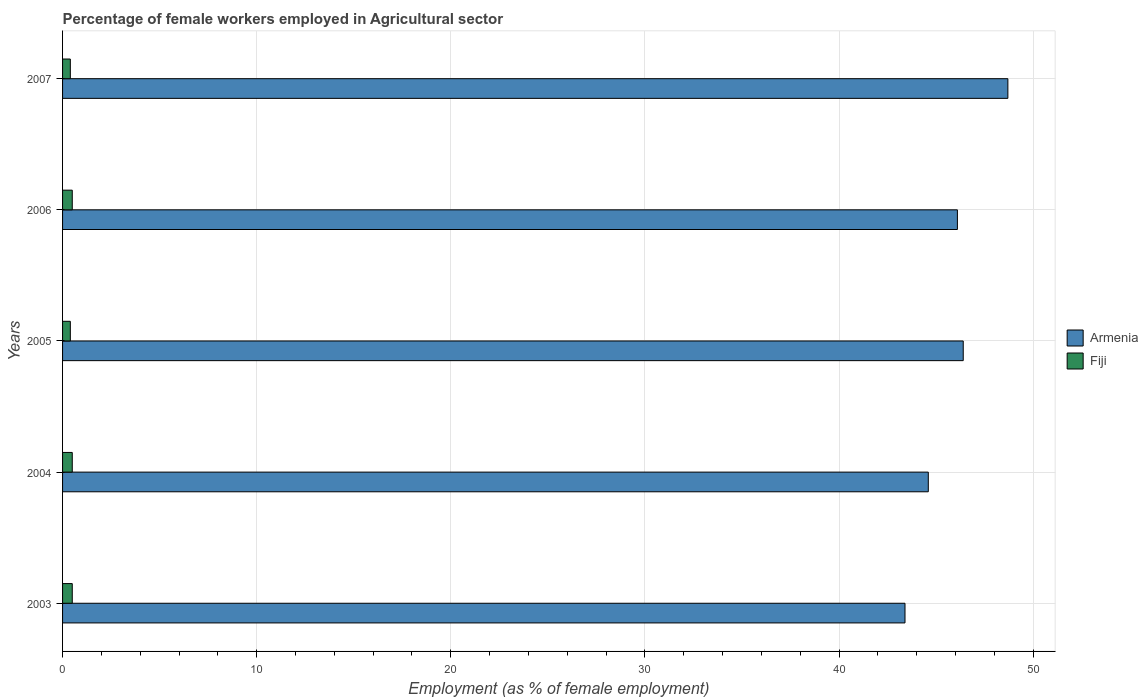Are the number of bars per tick equal to the number of legend labels?
Make the answer very short. Yes. Are the number of bars on each tick of the Y-axis equal?
Your answer should be compact. Yes. How many bars are there on the 3rd tick from the bottom?
Provide a succinct answer. 2. What is the label of the 4th group of bars from the top?
Ensure brevity in your answer.  2004. In how many cases, is the number of bars for a given year not equal to the number of legend labels?
Keep it short and to the point. 0. What is the percentage of females employed in Agricultural sector in Fiji in 2003?
Your answer should be compact. 0.5. Across all years, what is the maximum percentage of females employed in Agricultural sector in Fiji?
Provide a succinct answer. 0.5. Across all years, what is the minimum percentage of females employed in Agricultural sector in Fiji?
Ensure brevity in your answer.  0.4. In which year was the percentage of females employed in Agricultural sector in Fiji minimum?
Offer a very short reply. 2005. What is the total percentage of females employed in Agricultural sector in Fiji in the graph?
Give a very brief answer. 2.3. What is the difference between the percentage of females employed in Agricultural sector in Fiji in 2003 and that in 2005?
Ensure brevity in your answer.  0.1. What is the difference between the percentage of females employed in Agricultural sector in Armenia in 2004 and the percentage of females employed in Agricultural sector in Fiji in 2007?
Offer a terse response. 44.2. What is the average percentage of females employed in Agricultural sector in Armenia per year?
Your answer should be very brief. 45.84. In the year 2003, what is the difference between the percentage of females employed in Agricultural sector in Armenia and percentage of females employed in Agricultural sector in Fiji?
Provide a short and direct response. 42.9. In how many years, is the percentage of females employed in Agricultural sector in Armenia greater than 8 %?
Provide a succinct answer. 5. What is the ratio of the percentage of females employed in Agricultural sector in Fiji in 2004 to that in 2007?
Give a very brief answer. 1.25. Is the percentage of females employed in Agricultural sector in Armenia in 2003 less than that in 2005?
Ensure brevity in your answer.  Yes. What is the difference between the highest and the second highest percentage of females employed in Agricultural sector in Fiji?
Ensure brevity in your answer.  0. What is the difference between the highest and the lowest percentage of females employed in Agricultural sector in Armenia?
Ensure brevity in your answer.  5.3. Is the sum of the percentage of females employed in Agricultural sector in Armenia in 2005 and 2007 greater than the maximum percentage of females employed in Agricultural sector in Fiji across all years?
Provide a succinct answer. Yes. What does the 1st bar from the top in 2004 represents?
Make the answer very short. Fiji. What does the 2nd bar from the bottom in 2006 represents?
Offer a very short reply. Fiji. How many years are there in the graph?
Ensure brevity in your answer.  5. Are the values on the major ticks of X-axis written in scientific E-notation?
Give a very brief answer. No. Does the graph contain any zero values?
Ensure brevity in your answer.  No. Does the graph contain grids?
Give a very brief answer. Yes. What is the title of the graph?
Provide a short and direct response. Percentage of female workers employed in Agricultural sector. Does "Switzerland" appear as one of the legend labels in the graph?
Give a very brief answer. No. What is the label or title of the X-axis?
Your response must be concise. Employment (as % of female employment). What is the label or title of the Y-axis?
Offer a very short reply. Years. What is the Employment (as % of female employment) in Armenia in 2003?
Give a very brief answer. 43.4. What is the Employment (as % of female employment) of Armenia in 2004?
Give a very brief answer. 44.6. What is the Employment (as % of female employment) in Armenia in 2005?
Your answer should be very brief. 46.4. What is the Employment (as % of female employment) in Fiji in 2005?
Give a very brief answer. 0.4. What is the Employment (as % of female employment) of Armenia in 2006?
Give a very brief answer. 46.1. What is the Employment (as % of female employment) of Armenia in 2007?
Your response must be concise. 48.7. What is the Employment (as % of female employment) in Fiji in 2007?
Provide a succinct answer. 0.4. Across all years, what is the maximum Employment (as % of female employment) in Armenia?
Keep it short and to the point. 48.7. Across all years, what is the minimum Employment (as % of female employment) of Armenia?
Your answer should be compact. 43.4. Across all years, what is the minimum Employment (as % of female employment) in Fiji?
Your answer should be very brief. 0.4. What is the total Employment (as % of female employment) in Armenia in the graph?
Keep it short and to the point. 229.2. What is the difference between the Employment (as % of female employment) of Fiji in 2003 and that in 2004?
Your response must be concise. 0. What is the difference between the Employment (as % of female employment) of Armenia in 2004 and that in 2005?
Ensure brevity in your answer.  -1.8. What is the difference between the Employment (as % of female employment) of Fiji in 2004 and that in 2005?
Ensure brevity in your answer.  0.1. What is the difference between the Employment (as % of female employment) of Armenia in 2004 and that in 2007?
Ensure brevity in your answer.  -4.1. What is the difference between the Employment (as % of female employment) of Armenia in 2005 and that in 2006?
Keep it short and to the point. 0.3. What is the difference between the Employment (as % of female employment) of Fiji in 2005 and that in 2006?
Your response must be concise. -0.1. What is the difference between the Employment (as % of female employment) of Armenia in 2006 and that in 2007?
Your answer should be compact. -2.6. What is the difference between the Employment (as % of female employment) of Armenia in 2003 and the Employment (as % of female employment) of Fiji in 2004?
Your response must be concise. 42.9. What is the difference between the Employment (as % of female employment) of Armenia in 2003 and the Employment (as % of female employment) of Fiji in 2006?
Offer a terse response. 42.9. What is the difference between the Employment (as % of female employment) in Armenia in 2003 and the Employment (as % of female employment) in Fiji in 2007?
Offer a terse response. 43. What is the difference between the Employment (as % of female employment) in Armenia in 2004 and the Employment (as % of female employment) in Fiji in 2005?
Make the answer very short. 44.2. What is the difference between the Employment (as % of female employment) in Armenia in 2004 and the Employment (as % of female employment) in Fiji in 2006?
Offer a very short reply. 44.1. What is the difference between the Employment (as % of female employment) of Armenia in 2004 and the Employment (as % of female employment) of Fiji in 2007?
Offer a terse response. 44.2. What is the difference between the Employment (as % of female employment) in Armenia in 2005 and the Employment (as % of female employment) in Fiji in 2006?
Provide a short and direct response. 45.9. What is the difference between the Employment (as % of female employment) in Armenia in 2006 and the Employment (as % of female employment) in Fiji in 2007?
Keep it short and to the point. 45.7. What is the average Employment (as % of female employment) of Armenia per year?
Your response must be concise. 45.84. What is the average Employment (as % of female employment) of Fiji per year?
Provide a short and direct response. 0.46. In the year 2003, what is the difference between the Employment (as % of female employment) of Armenia and Employment (as % of female employment) of Fiji?
Keep it short and to the point. 42.9. In the year 2004, what is the difference between the Employment (as % of female employment) of Armenia and Employment (as % of female employment) of Fiji?
Offer a terse response. 44.1. In the year 2005, what is the difference between the Employment (as % of female employment) of Armenia and Employment (as % of female employment) of Fiji?
Your answer should be compact. 46. In the year 2006, what is the difference between the Employment (as % of female employment) in Armenia and Employment (as % of female employment) in Fiji?
Your answer should be compact. 45.6. In the year 2007, what is the difference between the Employment (as % of female employment) in Armenia and Employment (as % of female employment) in Fiji?
Offer a very short reply. 48.3. What is the ratio of the Employment (as % of female employment) of Armenia in 2003 to that in 2004?
Keep it short and to the point. 0.97. What is the ratio of the Employment (as % of female employment) in Fiji in 2003 to that in 2004?
Provide a succinct answer. 1. What is the ratio of the Employment (as % of female employment) of Armenia in 2003 to that in 2005?
Ensure brevity in your answer.  0.94. What is the ratio of the Employment (as % of female employment) of Armenia in 2003 to that in 2006?
Provide a succinct answer. 0.94. What is the ratio of the Employment (as % of female employment) of Armenia in 2003 to that in 2007?
Make the answer very short. 0.89. What is the ratio of the Employment (as % of female employment) in Fiji in 2003 to that in 2007?
Give a very brief answer. 1.25. What is the ratio of the Employment (as % of female employment) in Armenia in 2004 to that in 2005?
Provide a short and direct response. 0.96. What is the ratio of the Employment (as % of female employment) in Fiji in 2004 to that in 2005?
Provide a succinct answer. 1.25. What is the ratio of the Employment (as % of female employment) of Armenia in 2004 to that in 2006?
Keep it short and to the point. 0.97. What is the ratio of the Employment (as % of female employment) in Fiji in 2004 to that in 2006?
Ensure brevity in your answer.  1. What is the ratio of the Employment (as % of female employment) in Armenia in 2004 to that in 2007?
Make the answer very short. 0.92. What is the ratio of the Employment (as % of female employment) of Armenia in 2005 to that in 2006?
Give a very brief answer. 1.01. What is the ratio of the Employment (as % of female employment) in Armenia in 2005 to that in 2007?
Give a very brief answer. 0.95. What is the ratio of the Employment (as % of female employment) in Armenia in 2006 to that in 2007?
Your answer should be very brief. 0.95. What is the ratio of the Employment (as % of female employment) in Fiji in 2006 to that in 2007?
Provide a succinct answer. 1.25. What is the difference between the highest and the lowest Employment (as % of female employment) of Fiji?
Your response must be concise. 0.1. 